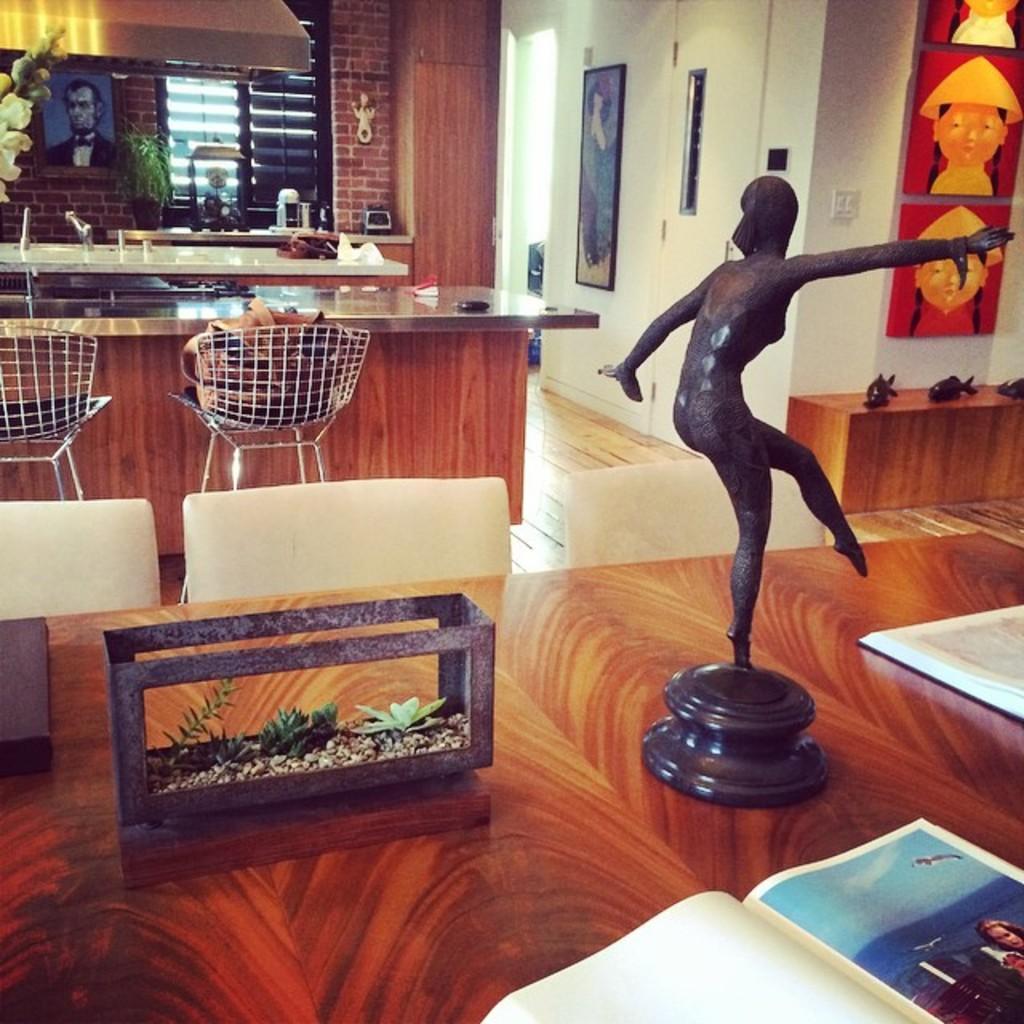Can you describe this image briefly? There is a table ,kitchen and chairs on the left side. There is a another table and statute on the right side. There is a table in the center. We can see in the background photo frame ,wall,socket ,lights. 